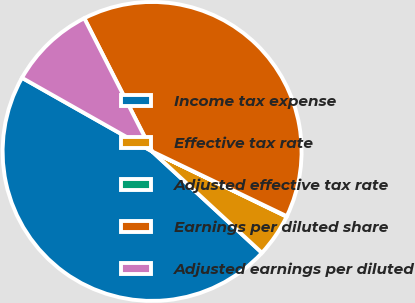Convert chart. <chart><loc_0><loc_0><loc_500><loc_500><pie_chart><fcel>Income tax expense<fcel>Effective tax rate<fcel>Adjusted effective tax rate<fcel>Earnings per diluted share<fcel>Adjusted earnings per diluted<nl><fcel>46.33%<fcel>4.68%<fcel>0.05%<fcel>39.63%<fcel>9.31%<nl></chart> 